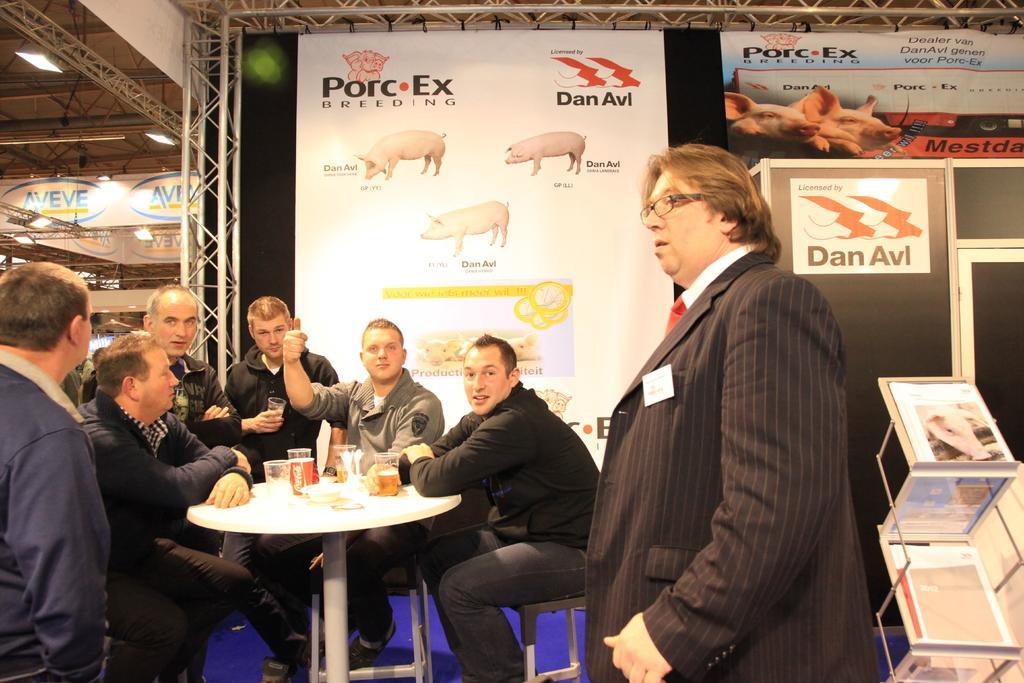Please provide a concise description of this image. In this image there are some peoples sitting on the chairs. There is a table on which some glasses are kept and some food items are there and a man standing who is wearing a black coat and there is a table on which some books a kept and in the background there is wall on which some posters a pasted. 